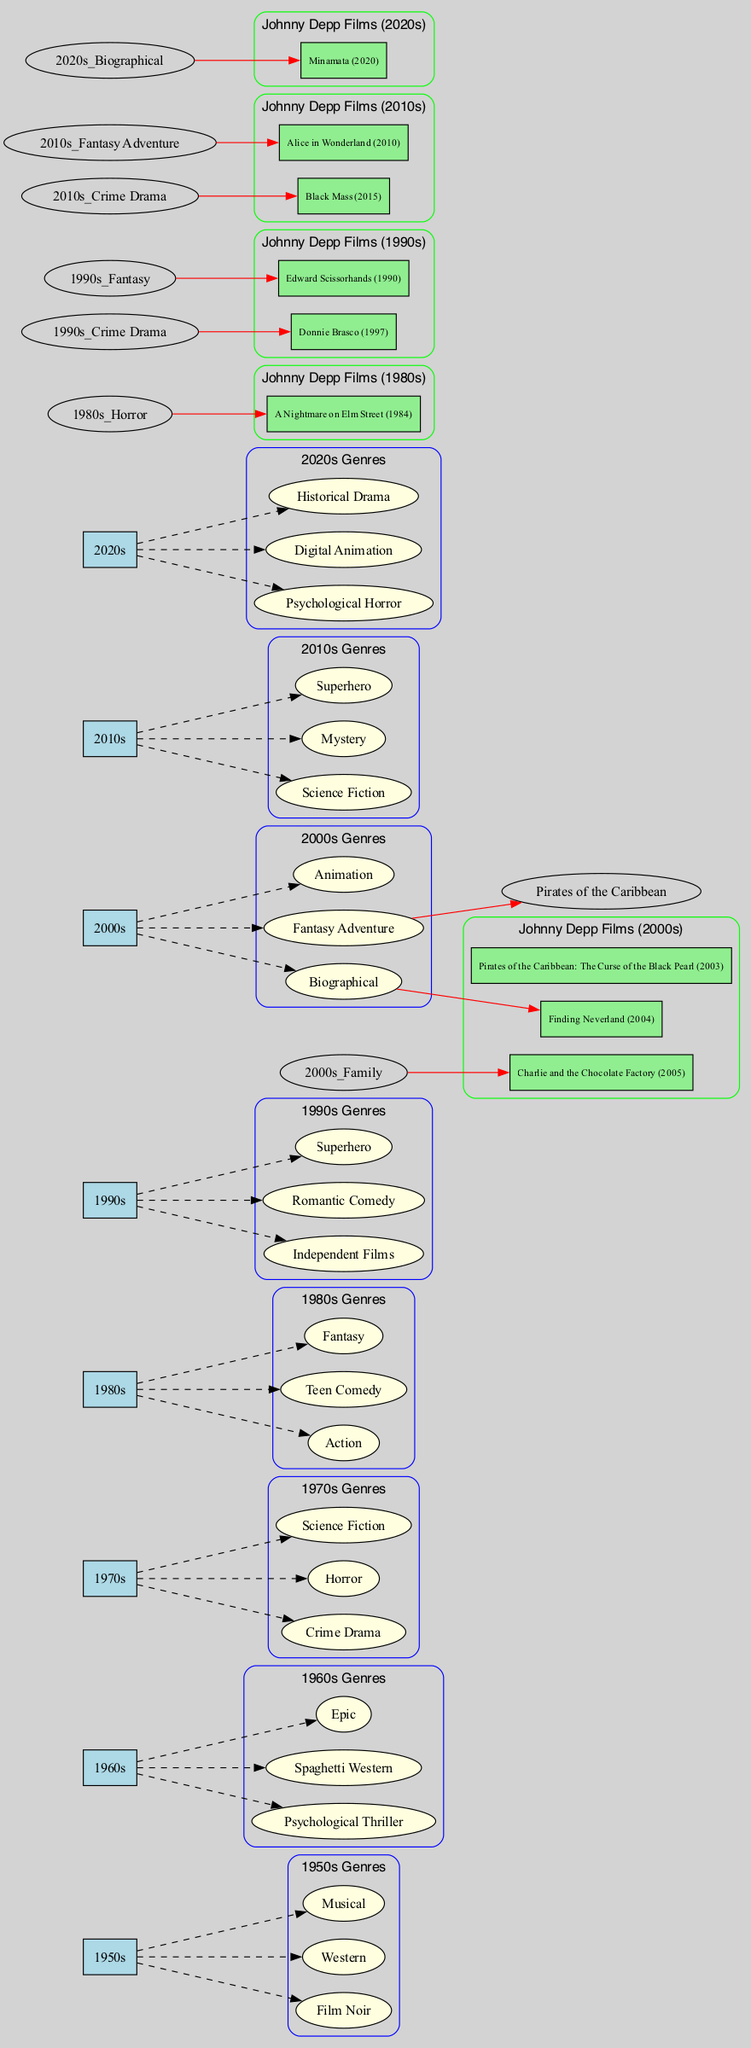What genres are present in the 1970s? Looking at the diagram, the node for the 1970s connects to three genre nodes: Crime Drama, Horror, and Science Fiction.
Answer: Crime Drama, Horror, Science Fiction Which genre is linked to "A Nightmare on Elm Street"? Tracing back from the film node "A Nightmare on Elm Street", it connects to the Horror genre within the 1980s decade.
Answer: Horror How many film genres are shown in the 2020s? The diagram displays three genre nodes under the 2020s: Psychological Horror, Digital Animation, and Historical Drama, totaling three genres.
Answer: 3 What is the common genre for Johnny Depp's films in the 1990s? In the 1990s, Johnny Depp's films are linked to two genres: Fantasy from "Edward Scissorhands" and Crime Drama from "Donnie Brasco". The common genre must be identified by their direct connections, which is Crime Drama.
Answer: Crime Drama Which film from the 2000s belongs to the Fantasy Adventure genre? The 2000s decade node connects to "Pirates of the Caribbean: The Curse of the Black Pearl", which is specifically categorized under the Fantasy Adventure genre.
Answer: Pirates of the Caribbean: The Curse of the Black Pearl Which decade had the most genres listed? By examining the diagram closely, we find that the decade with the most genres is the 1990s, which has three genres: Independent Films, Romantic Comedy, and Superhero.
Answer: 1990s How many films did Johnny Depp star in during the 2010s? In the diagram, the 2010s decade contains two films: "Alice in Wonderland" and "Black Mass", indicating that he starred in two films during this decade.
Answer: 2 In which genre from the 2000s did Johnny Depp act that is not a sequel? From the 2000s decade, "Finding Neverland" is the film that belongs to the Biographical genre and is recognized as an original story without a sequel.
Answer: Finding Neverland 